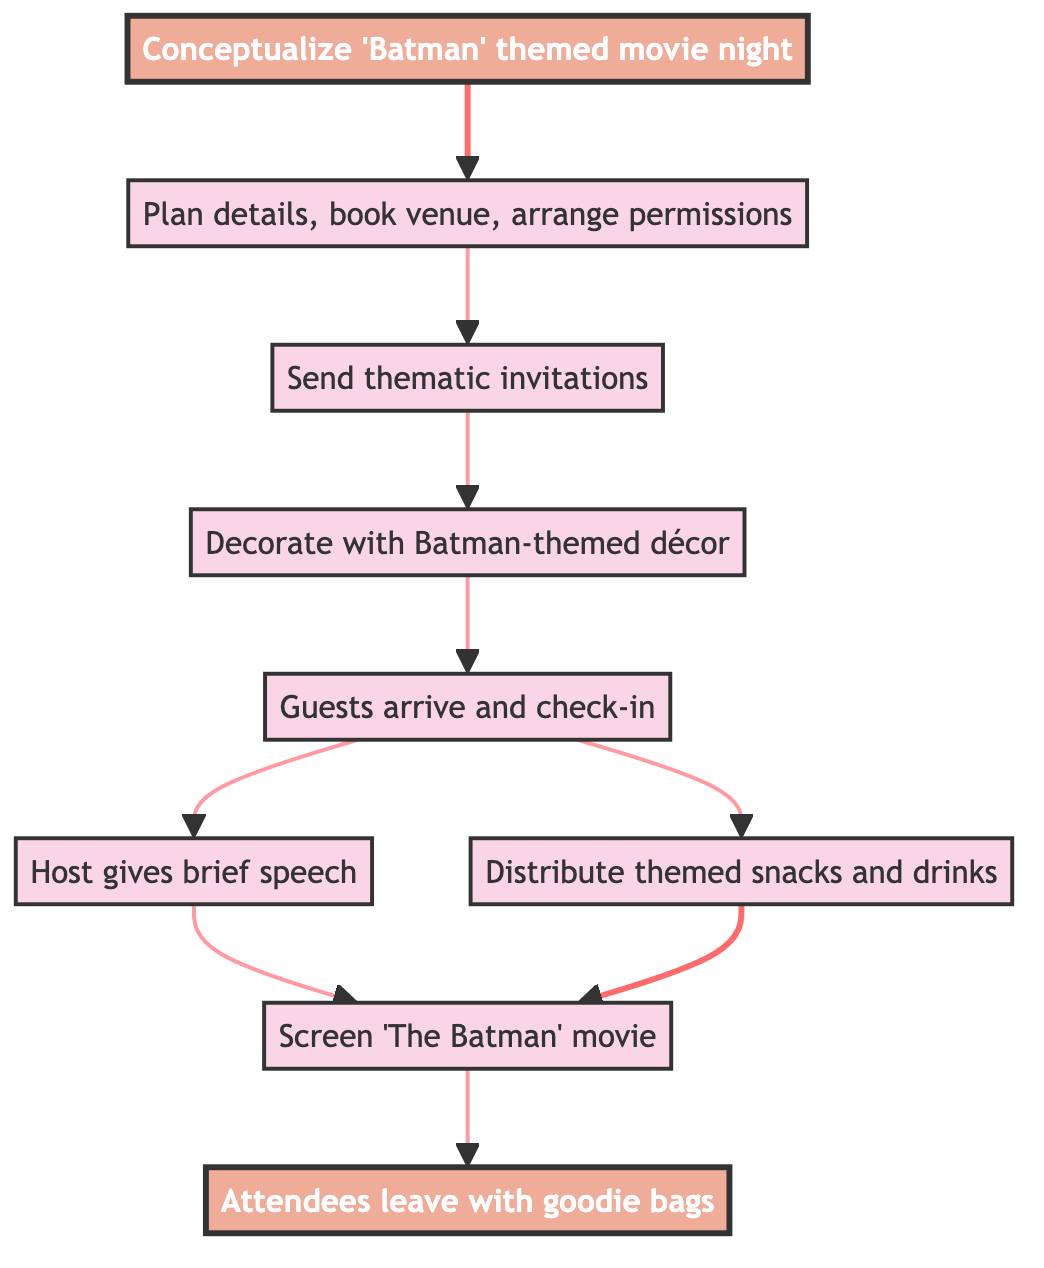What is the first step in organizing the event? The first step in organizing the event is conceptualizing the idea of hosting a "Batman" themed movie night, which is represented as the starting node "Event Idea" in the diagram.
Answer: Event Idea How many nodes are in the diagram? The diagram contains a total of 9 nodes, representing various stages in organizing the movie night event from beginning to end.
Answer: 9 What is the final step attendees experience? The final step that attendees experience is leaving with goodie bags and sharing their experiences on social media, noted as the "End Event" node in the diagram.
Answer: End Event What node comes after "Attendee Arrival"? After "Attendee Arrival," the next nodes are "Welcome Speech" and "Snack and Drink Distribution," indicating that both actions can occur simultaneously following the arrival of guests.
Answer: Welcome Speech, Snack and Drink Distribution Which node has no dependencies? The node "Event Idea" has no dependencies, as it is the starting point of the flow chart that initiates the entire event planning process.
Answer: Event Idea What is required before "Venue Decoration" can happen? "Planning and Preparation" is required before "Venue Decoration" can happen, as it is the node that leads to the distribution of invitations and the overall setup of the event space.
Answer: Planning and Preparation How many actions must occur before "Movie Screening"? Two actions must occur before "Movie Screening": "Welcome Speech" and "Snack and Drink Distribution," both of which must follow attendee arrival.
Answer: 2 Which node directly leads into the "Movie Screening"? The nodes that directly lead into "Movie Screening" are "Welcome Speech" and "Snack and Drink Distribution," indicating that both must be completed before screening the movie.
Answer: Welcome Speech, Snack and Drink Distribution What happens immediately after "Invitation Distribution"? Immediately after "Invitation Distribution," the next action is "Venue Decoration," indicating that the venue will be prepared after invitations have been sent out.
Answer: Venue Decoration 